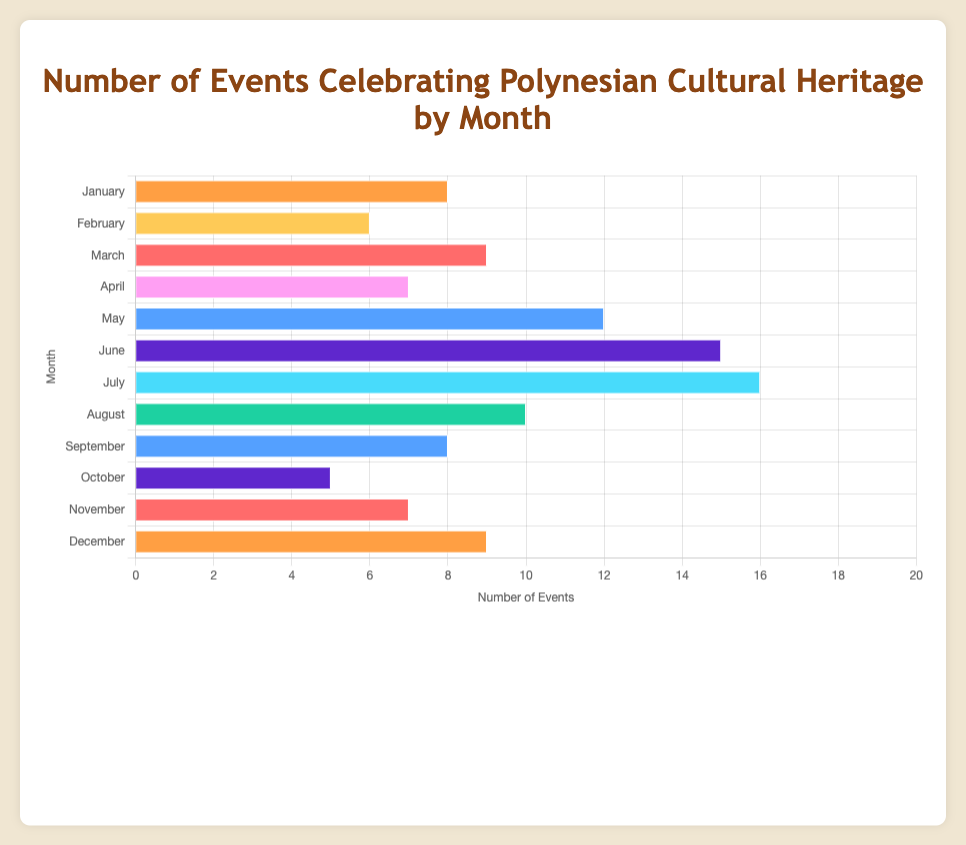What's the month with the highest number of events? By examining the horizontal bars, July has the longest bar, representing the highest number of events.
Answer: July Which month has more events, March or November? The bar for March is longer than the bar for November. March has 9 events while November has 7.
Answer: March How many more events are there in June compared to February? June has 15 events, and February has 6 events. Therefore, the difference in the number of events is 15 - 6 = 9.
Answer: 9 What is the median number of events per month? Arrange the number of events per month in ascending order: 5, 6, 7, 7, 8, 8, 9, 9, 10, 12, 15, 16. The median is the average of the 6th and 7th values in the list (8 and 9), so (8+9)/2 = 8.5
Answer: 8.5 Which months have an equal number of events? By comparing the lengths of the bars, January and September both have 8 events; March and December both have 9 events.
Answer: January and September, March and December What is the major event in the month with the third-highest number of events? After July (16 events), and June (15 events), May has the third highest number of events (12 events). The major event in May is the "Te Moana Nui Traditional Crafts Fair".
Answer: Te Moana Nui Traditional Crafts Fair What is the range of the number of events across all months? The range is the difference between the maximum and minimum values. The highest number is 16 in July and the lowest is 5 in October. Therefore, the range is 16 - 5 = 11.
Answer: 11 How does the number of events in April compare to December? By comparing the bars visually, both have a nearly equal length, but April has 7 events, and December has 9 events. April has fewer events than December.
Answer: April has fewer events What's the average number of events per month? Sum all the events: 8 + 6 + 9 + 7 + 12 + 15 + 16 + 10 + 8 + 5 + 7 + 9 = 112. Divide by the number of months (12): 112 / 12 = 9.33
Answer: 9.33 